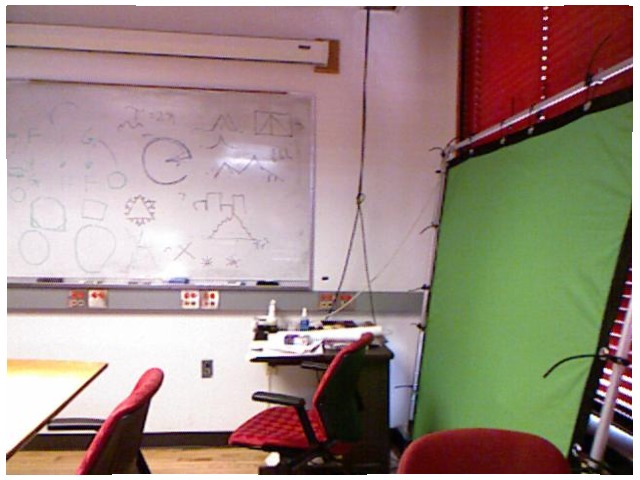<image>
Is there a chair under the table? No. The chair is not positioned under the table. The vertical relationship between these objects is different. Is the chair on the screen? No. The chair is not positioned on the screen. They may be near each other, but the chair is not supported by or resting on top of the screen. Is there a white board behind the chair? Yes. From this viewpoint, the white board is positioned behind the chair, with the chair partially or fully occluding the white board. 